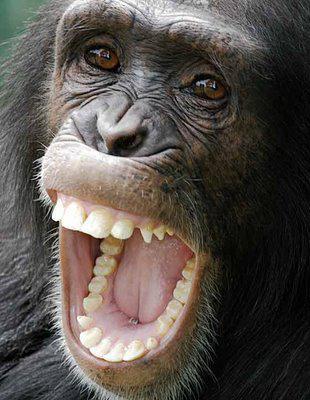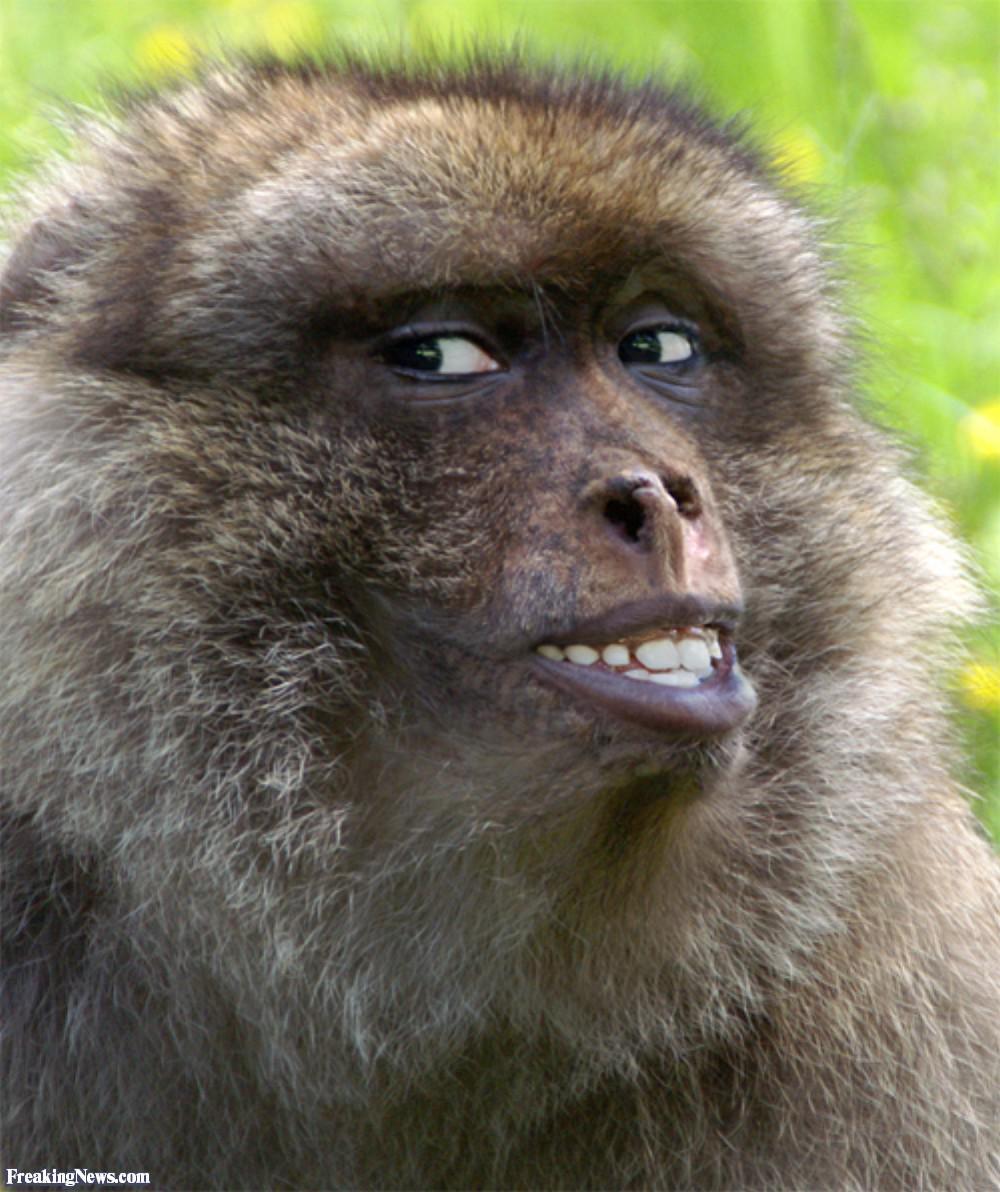The first image is the image on the left, the second image is the image on the right. Examine the images to the left and right. Is the description "Each image contains the face of an ape with teeth showing, and at least one image shows a wide-open mouth." accurate? Answer yes or no. Yes. The first image is the image on the left, the second image is the image on the right. For the images shown, is this caption "The primate in the image on the left has its mouth wide open." true? Answer yes or no. Yes. 